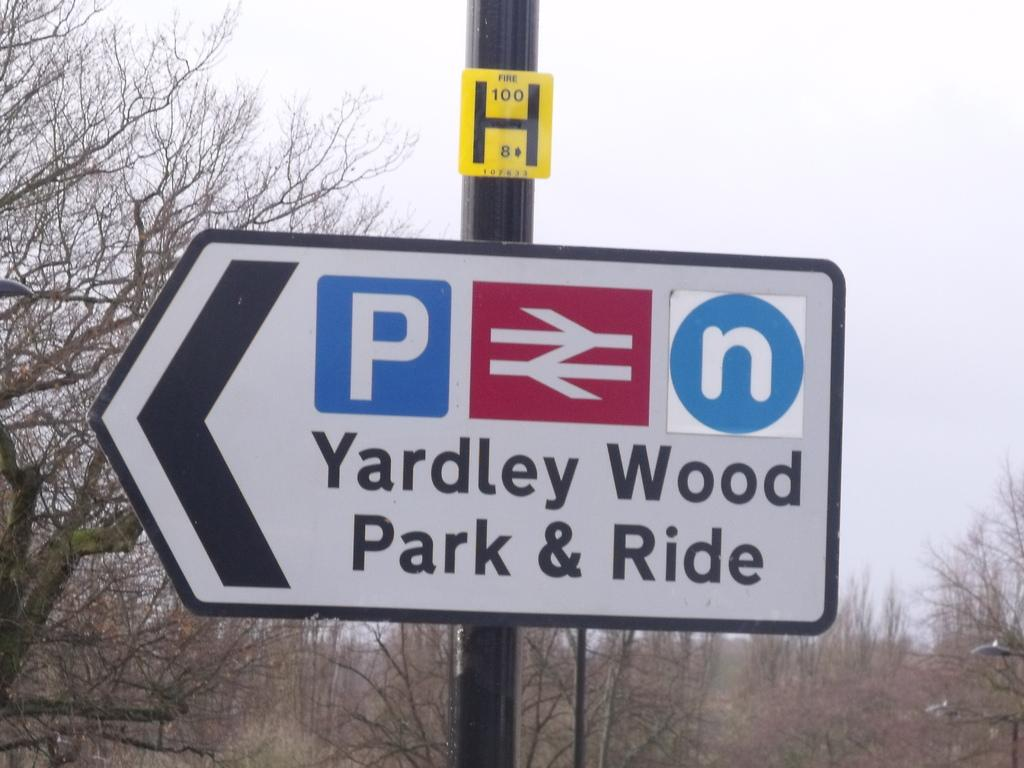Provide a one-sentence caption for the provided image. A sign for Yardley Wood Park and Ride points to the left. 